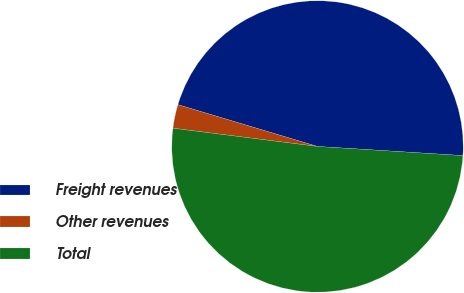<chart> <loc_0><loc_0><loc_500><loc_500><pie_chart><fcel>Freight revenues<fcel>Other revenues<fcel>Total<nl><fcel>46.37%<fcel>2.63%<fcel>51.0%<nl></chart> 